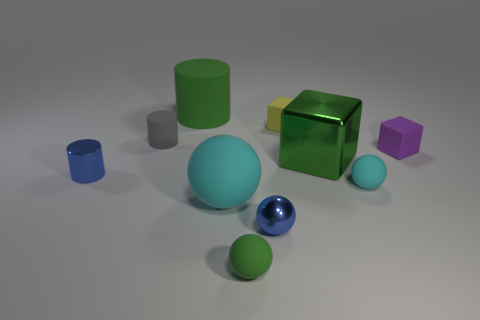What size is the green thing that is in front of the tiny blue metallic object that is on the left side of the small blue thing that is in front of the blue cylinder?
Ensure brevity in your answer.  Small. What shape is the green object that is the same size as the green metal block?
Provide a succinct answer. Cylinder. Is there any other thing that is the same material as the small gray thing?
Your answer should be compact. Yes. How many things are small balls to the left of the large block or big blue rubber cylinders?
Your answer should be very brief. 2. Is there a tiny blue metallic object behind the blue object that is to the right of the blue metal object that is on the left side of the large cyan rubber object?
Your response must be concise. Yes. What number of big things are there?
Keep it short and to the point. 3. What number of things are either green cubes behind the green matte sphere or large green things that are to the right of the green ball?
Offer a very short reply. 1. Do the blue sphere in front of the gray cylinder and the small green object have the same size?
Keep it short and to the point. Yes. The green matte thing that is the same shape as the small cyan rubber thing is what size?
Provide a succinct answer. Small. What material is the green thing that is the same size as the yellow thing?
Your response must be concise. Rubber. 